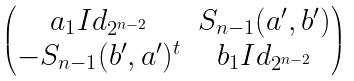<formula> <loc_0><loc_0><loc_500><loc_500>\begin{pmatrix} a _ { 1 } I d _ { 2 ^ { n - 2 } } & S _ { n - 1 } ( a ^ { \prime } , b ^ { \prime } ) \\ - S _ { n - 1 } ( b ^ { \prime } , a ^ { \prime } ) ^ { t } & b _ { 1 } I d _ { 2 ^ { n - 2 } } \end{pmatrix}</formula> 